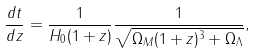<formula> <loc_0><loc_0><loc_500><loc_500>\frac { d t } { d z } = \frac { 1 } { H _ { 0 } ( 1 + z ) } \frac { 1 } { \sqrt { \Omega _ { M } ( 1 + z ) ^ { 3 } + \Omega _ { \Lambda } } } ,</formula> 